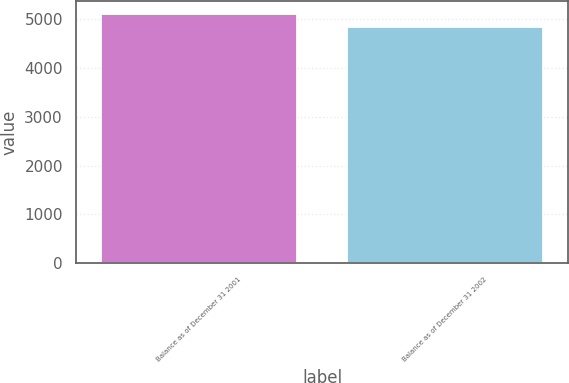<chart> <loc_0><loc_0><loc_500><loc_500><bar_chart><fcel>Balance as of December 31 2001<fcel>Balance as of December 31 2002<nl><fcel>5119<fcel>4836<nl></chart> 